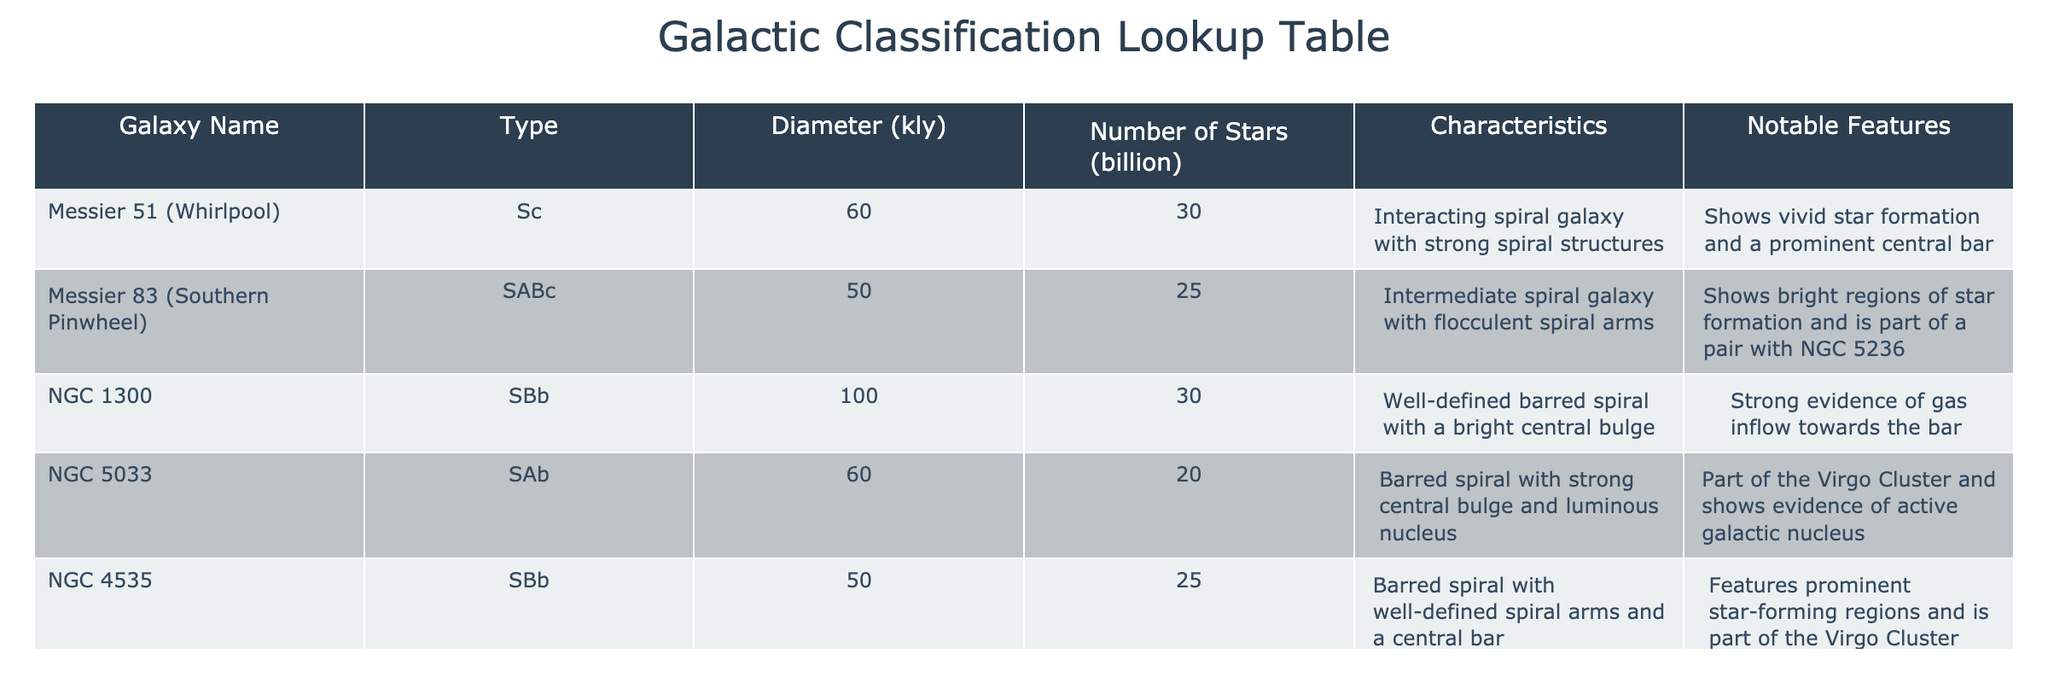What is the diameter of Messier 51? The diameter of Messier 51 is listed in the table under the "Diameter (kly)" column. It shows as 60 kly.
Answer: 60 kly How many stars does NGC 5033 have? The "Number of Stars (billion)" column for NGC 5033 indicates it has 20 billion stars.
Answer: 20 billion Which galaxy has the largest number of stars? To find the galaxy with the largest number of stars, we can compare the values in the "Number of Stars (billion)" column. NGC 7331 has 45 billion stars, which is greater than the others.
Answer: NGC 7331 Is NGC 1300 a barred spiral galaxy? Checking the "Type" column for NGC 1300, it confirms that it is labeled as SBb, which denotes a barred spiral type.
Answer: Yes What is the average diameter of the listed galaxies? To calculate the average diameter, sum the diameters of the galaxies: (60 + 50 + 100 + 60 + 50 + 100) = 420 kly. Dividing by 6 (the number of galaxies) gives an average of 70 kly.
Answer: 70 kly Which galaxies are part of the Virgo Cluster? The table mentions that NGC 5033 and NGC 4535 are part of the Virgo Cluster. This can be found in the "Characteristics" section.
Answer: NGC 5033, NGC 4535 How many galaxies listed have a strong central bulge? Looking through the "Characteristics" column, both NGC 1300 and NGC 5033 specifically mention having a strong central bulge. This requires identifying the descriptions to find the specific traits.
Answer: 2 What characteristics define Messier 83? To understand the characteristics of Messier 83, we can refer to the "Characteristics" column where it is described as an intermediate spiral galaxy with flocculent spiral arms.
Answer: Intermediate spiral with flocculent arms Which galaxy shows evidence of gas inflow towards the bar? The table states in the "Characteristics" of NGC 1300 that there is strong evidence of gas inflow towards the bar, making it the correct answer.
Answer: NGC 1300 